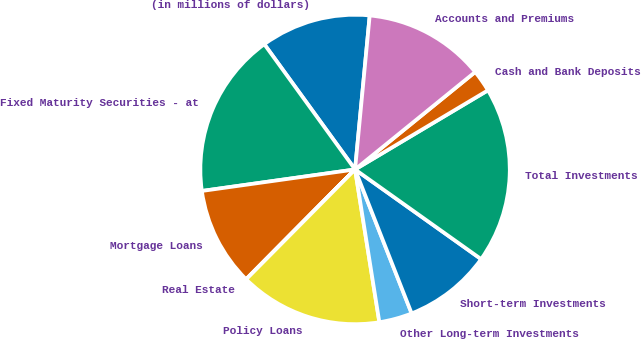Convert chart. <chart><loc_0><loc_0><loc_500><loc_500><pie_chart><fcel>(in millions of dollars)<fcel>Fixed Maturity Securities - at<fcel>Mortgage Loans<fcel>Real Estate<fcel>Policy Loans<fcel>Other Long-term Investments<fcel>Short-term Investments<fcel>Total Investments<fcel>Cash and Bank Deposits<fcel>Accounts and Premiums<nl><fcel>11.49%<fcel>17.24%<fcel>10.34%<fcel>0.01%<fcel>14.94%<fcel>3.45%<fcel>9.2%<fcel>18.39%<fcel>2.3%<fcel>12.64%<nl></chart> 